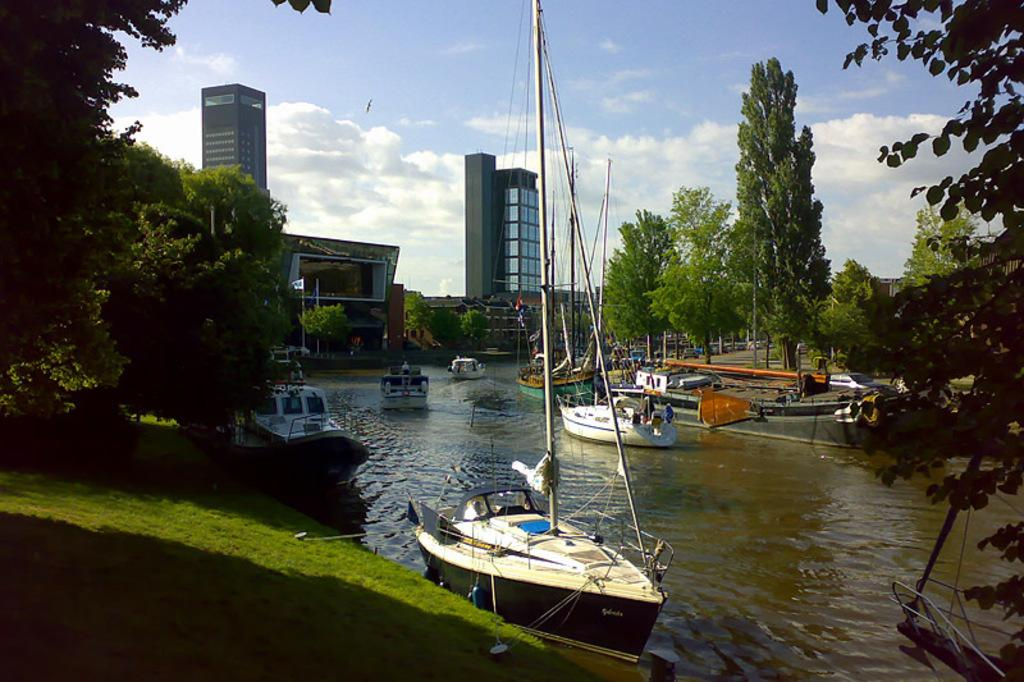What type of surface is visible in the image? There is a grass surface in the image. What natural feature can be seen in the image? There is a river in the image. What is on the river in the image? There are ships on the river. What type of structures are visible in the image? There are buildings visible in the image. What type of vegetation is present in the image? There are trees in the image. Can you see a receipt for the ships on the river in the image? There is no receipt present in the image. Is there any indication of a flight in the image? There is no mention or indication of a flight in the image. 